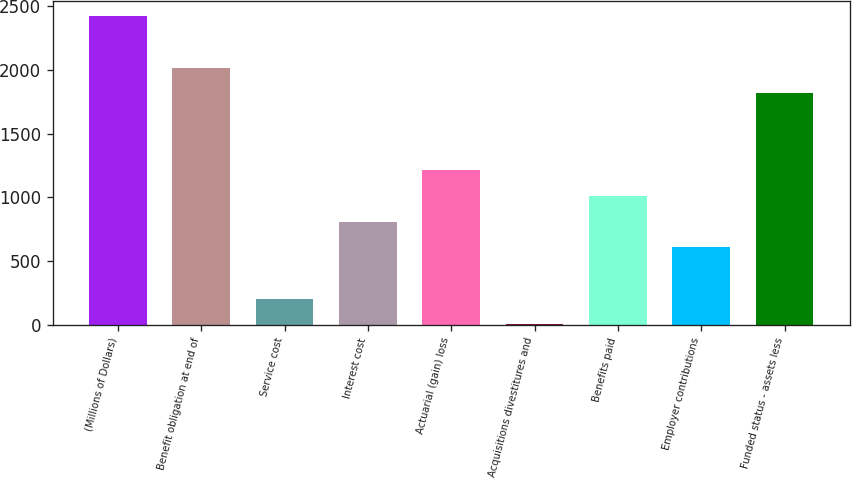Convert chart. <chart><loc_0><loc_0><loc_500><loc_500><bar_chart><fcel>(Millions of Dollars)<fcel>Benefit obligation at end of<fcel>Service cost<fcel>Interest cost<fcel>Actuarial (gain) loss<fcel>Acquisitions divestitures and<fcel>Benefits paid<fcel>Employer contributions<fcel>Funded status - assets less<nl><fcel>2420.92<fcel>2018<fcel>204.86<fcel>809.24<fcel>1212.16<fcel>3.4<fcel>1010.7<fcel>607.78<fcel>1816.54<nl></chart> 